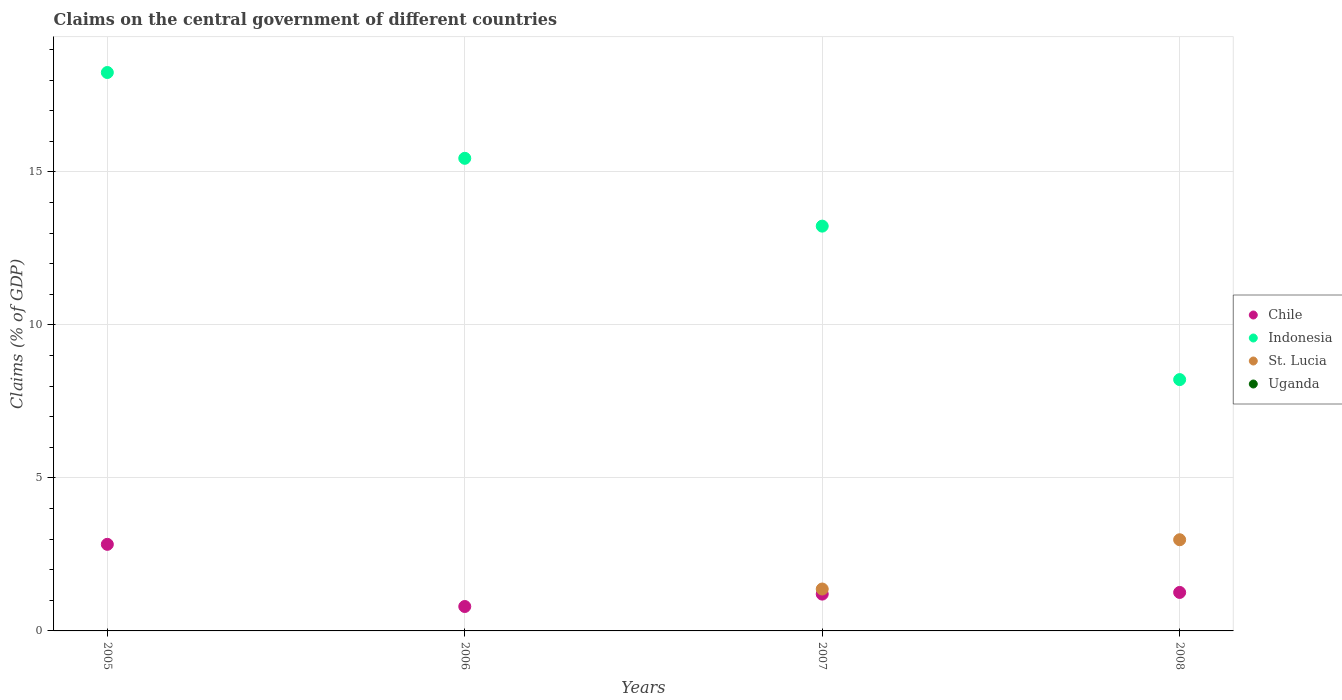Is the number of dotlines equal to the number of legend labels?
Give a very brief answer. No. What is the percentage of GDP claimed on the central government in Indonesia in 2006?
Your answer should be compact. 15.44. Across all years, what is the maximum percentage of GDP claimed on the central government in Indonesia?
Make the answer very short. 18.25. Across all years, what is the minimum percentage of GDP claimed on the central government in St. Lucia?
Provide a short and direct response. 0. What is the total percentage of GDP claimed on the central government in St. Lucia in the graph?
Your answer should be very brief. 4.35. What is the difference between the percentage of GDP claimed on the central government in Chile in 2006 and that in 2007?
Provide a short and direct response. -0.41. What is the difference between the percentage of GDP claimed on the central government in Chile in 2006 and the percentage of GDP claimed on the central government in St. Lucia in 2008?
Your response must be concise. -2.18. What is the average percentage of GDP claimed on the central government in Chile per year?
Your answer should be compact. 1.52. In the year 2007, what is the difference between the percentage of GDP claimed on the central government in St. Lucia and percentage of GDP claimed on the central government in Indonesia?
Give a very brief answer. -11.86. What is the ratio of the percentage of GDP claimed on the central government in Chile in 2005 to that in 2007?
Keep it short and to the point. 2.35. What is the difference between the highest and the second highest percentage of GDP claimed on the central government in Indonesia?
Your answer should be compact. 2.8. What is the difference between the highest and the lowest percentage of GDP claimed on the central government in Chile?
Offer a very short reply. 2.03. In how many years, is the percentage of GDP claimed on the central government in Uganda greater than the average percentage of GDP claimed on the central government in Uganda taken over all years?
Ensure brevity in your answer.  0. Is the sum of the percentage of GDP claimed on the central government in Chile in 2005 and 2006 greater than the maximum percentage of GDP claimed on the central government in Uganda across all years?
Provide a short and direct response. Yes. Does the percentage of GDP claimed on the central government in Chile monotonically increase over the years?
Your answer should be very brief. No. Is the percentage of GDP claimed on the central government in Uganda strictly less than the percentage of GDP claimed on the central government in Indonesia over the years?
Provide a succinct answer. Yes. How many dotlines are there?
Ensure brevity in your answer.  3. How many years are there in the graph?
Provide a short and direct response. 4. What is the difference between two consecutive major ticks on the Y-axis?
Your answer should be compact. 5. How are the legend labels stacked?
Keep it short and to the point. Vertical. What is the title of the graph?
Give a very brief answer. Claims on the central government of different countries. What is the label or title of the Y-axis?
Make the answer very short. Claims (% of GDP). What is the Claims (% of GDP) of Chile in 2005?
Your response must be concise. 2.83. What is the Claims (% of GDP) in Indonesia in 2005?
Your answer should be compact. 18.25. What is the Claims (% of GDP) of St. Lucia in 2005?
Provide a short and direct response. 0. What is the Claims (% of GDP) in Uganda in 2005?
Your answer should be compact. 0. What is the Claims (% of GDP) of Chile in 2006?
Your answer should be very brief. 0.8. What is the Claims (% of GDP) of Indonesia in 2006?
Give a very brief answer. 15.44. What is the Claims (% of GDP) in Chile in 2007?
Your response must be concise. 1.2. What is the Claims (% of GDP) in Indonesia in 2007?
Offer a very short reply. 13.23. What is the Claims (% of GDP) in St. Lucia in 2007?
Your answer should be very brief. 1.37. What is the Claims (% of GDP) of Uganda in 2007?
Ensure brevity in your answer.  0. What is the Claims (% of GDP) of Chile in 2008?
Your answer should be very brief. 1.26. What is the Claims (% of GDP) in Indonesia in 2008?
Make the answer very short. 8.21. What is the Claims (% of GDP) in St. Lucia in 2008?
Your answer should be compact. 2.98. What is the Claims (% of GDP) of Uganda in 2008?
Your response must be concise. 0. Across all years, what is the maximum Claims (% of GDP) in Chile?
Offer a very short reply. 2.83. Across all years, what is the maximum Claims (% of GDP) in Indonesia?
Give a very brief answer. 18.25. Across all years, what is the maximum Claims (% of GDP) in St. Lucia?
Give a very brief answer. 2.98. Across all years, what is the minimum Claims (% of GDP) in Chile?
Your answer should be very brief. 0.8. Across all years, what is the minimum Claims (% of GDP) in Indonesia?
Your answer should be compact. 8.21. What is the total Claims (% of GDP) in Chile in the graph?
Your answer should be very brief. 6.09. What is the total Claims (% of GDP) in Indonesia in the graph?
Offer a very short reply. 55.13. What is the total Claims (% of GDP) of St. Lucia in the graph?
Keep it short and to the point. 4.35. What is the difference between the Claims (% of GDP) of Chile in 2005 and that in 2006?
Provide a succinct answer. 2.03. What is the difference between the Claims (% of GDP) in Indonesia in 2005 and that in 2006?
Provide a short and direct response. 2.8. What is the difference between the Claims (% of GDP) in Chile in 2005 and that in 2007?
Your answer should be very brief. 1.63. What is the difference between the Claims (% of GDP) in Indonesia in 2005 and that in 2007?
Provide a succinct answer. 5.02. What is the difference between the Claims (% of GDP) of Chile in 2005 and that in 2008?
Give a very brief answer. 1.57. What is the difference between the Claims (% of GDP) in Indonesia in 2005 and that in 2008?
Provide a succinct answer. 10.03. What is the difference between the Claims (% of GDP) in Chile in 2006 and that in 2007?
Provide a succinct answer. -0.41. What is the difference between the Claims (% of GDP) in Indonesia in 2006 and that in 2007?
Offer a terse response. 2.22. What is the difference between the Claims (% of GDP) of Chile in 2006 and that in 2008?
Offer a very short reply. -0.46. What is the difference between the Claims (% of GDP) in Indonesia in 2006 and that in 2008?
Your answer should be very brief. 7.23. What is the difference between the Claims (% of GDP) in Chile in 2007 and that in 2008?
Your answer should be compact. -0.05. What is the difference between the Claims (% of GDP) in Indonesia in 2007 and that in 2008?
Make the answer very short. 5.01. What is the difference between the Claims (% of GDP) of St. Lucia in 2007 and that in 2008?
Your answer should be very brief. -1.61. What is the difference between the Claims (% of GDP) in Chile in 2005 and the Claims (% of GDP) in Indonesia in 2006?
Provide a short and direct response. -12.61. What is the difference between the Claims (% of GDP) of Chile in 2005 and the Claims (% of GDP) of Indonesia in 2007?
Your response must be concise. -10.4. What is the difference between the Claims (% of GDP) in Chile in 2005 and the Claims (% of GDP) in St. Lucia in 2007?
Provide a short and direct response. 1.46. What is the difference between the Claims (% of GDP) in Indonesia in 2005 and the Claims (% of GDP) in St. Lucia in 2007?
Your answer should be very brief. 16.88. What is the difference between the Claims (% of GDP) of Chile in 2005 and the Claims (% of GDP) of Indonesia in 2008?
Your response must be concise. -5.38. What is the difference between the Claims (% of GDP) in Chile in 2005 and the Claims (% of GDP) in St. Lucia in 2008?
Provide a short and direct response. -0.15. What is the difference between the Claims (% of GDP) of Indonesia in 2005 and the Claims (% of GDP) of St. Lucia in 2008?
Keep it short and to the point. 15.27. What is the difference between the Claims (% of GDP) of Chile in 2006 and the Claims (% of GDP) of Indonesia in 2007?
Keep it short and to the point. -12.43. What is the difference between the Claims (% of GDP) of Chile in 2006 and the Claims (% of GDP) of St. Lucia in 2007?
Keep it short and to the point. -0.57. What is the difference between the Claims (% of GDP) of Indonesia in 2006 and the Claims (% of GDP) of St. Lucia in 2007?
Your answer should be compact. 14.07. What is the difference between the Claims (% of GDP) in Chile in 2006 and the Claims (% of GDP) in Indonesia in 2008?
Give a very brief answer. -7.41. What is the difference between the Claims (% of GDP) in Chile in 2006 and the Claims (% of GDP) in St. Lucia in 2008?
Keep it short and to the point. -2.18. What is the difference between the Claims (% of GDP) of Indonesia in 2006 and the Claims (% of GDP) of St. Lucia in 2008?
Offer a very short reply. 12.46. What is the difference between the Claims (% of GDP) in Chile in 2007 and the Claims (% of GDP) in Indonesia in 2008?
Offer a very short reply. -7.01. What is the difference between the Claims (% of GDP) of Chile in 2007 and the Claims (% of GDP) of St. Lucia in 2008?
Make the answer very short. -1.78. What is the difference between the Claims (% of GDP) in Indonesia in 2007 and the Claims (% of GDP) in St. Lucia in 2008?
Your answer should be very brief. 10.25. What is the average Claims (% of GDP) in Chile per year?
Offer a very short reply. 1.52. What is the average Claims (% of GDP) in Indonesia per year?
Offer a terse response. 13.78. What is the average Claims (% of GDP) in St. Lucia per year?
Provide a short and direct response. 1.09. In the year 2005, what is the difference between the Claims (% of GDP) of Chile and Claims (% of GDP) of Indonesia?
Your answer should be very brief. -15.42. In the year 2006, what is the difference between the Claims (% of GDP) in Chile and Claims (% of GDP) in Indonesia?
Ensure brevity in your answer.  -14.64. In the year 2007, what is the difference between the Claims (% of GDP) in Chile and Claims (% of GDP) in Indonesia?
Provide a succinct answer. -12.02. In the year 2007, what is the difference between the Claims (% of GDP) in Chile and Claims (% of GDP) in St. Lucia?
Your answer should be very brief. -0.17. In the year 2007, what is the difference between the Claims (% of GDP) in Indonesia and Claims (% of GDP) in St. Lucia?
Ensure brevity in your answer.  11.86. In the year 2008, what is the difference between the Claims (% of GDP) in Chile and Claims (% of GDP) in Indonesia?
Give a very brief answer. -6.95. In the year 2008, what is the difference between the Claims (% of GDP) of Chile and Claims (% of GDP) of St. Lucia?
Give a very brief answer. -1.72. In the year 2008, what is the difference between the Claims (% of GDP) of Indonesia and Claims (% of GDP) of St. Lucia?
Keep it short and to the point. 5.23. What is the ratio of the Claims (% of GDP) of Chile in 2005 to that in 2006?
Keep it short and to the point. 3.55. What is the ratio of the Claims (% of GDP) of Indonesia in 2005 to that in 2006?
Give a very brief answer. 1.18. What is the ratio of the Claims (% of GDP) in Chile in 2005 to that in 2007?
Give a very brief answer. 2.35. What is the ratio of the Claims (% of GDP) of Indonesia in 2005 to that in 2007?
Provide a succinct answer. 1.38. What is the ratio of the Claims (% of GDP) of Chile in 2005 to that in 2008?
Give a very brief answer. 2.25. What is the ratio of the Claims (% of GDP) of Indonesia in 2005 to that in 2008?
Ensure brevity in your answer.  2.22. What is the ratio of the Claims (% of GDP) in Chile in 2006 to that in 2007?
Make the answer very short. 0.66. What is the ratio of the Claims (% of GDP) of Indonesia in 2006 to that in 2007?
Ensure brevity in your answer.  1.17. What is the ratio of the Claims (% of GDP) of Chile in 2006 to that in 2008?
Your response must be concise. 0.63. What is the ratio of the Claims (% of GDP) in Indonesia in 2006 to that in 2008?
Offer a very short reply. 1.88. What is the ratio of the Claims (% of GDP) of Chile in 2007 to that in 2008?
Make the answer very short. 0.96. What is the ratio of the Claims (% of GDP) in Indonesia in 2007 to that in 2008?
Provide a short and direct response. 1.61. What is the ratio of the Claims (% of GDP) of St. Lucia in 2007 to that in 2008?
Offer a very short reply. 0.46. What is the difference between the highest and the second highest Claims (% of GDP) of Chile?
Offer a very short reply. 1.57. What is the difference between the highest and the second highest Claims (% of GDP) in Indonesia?
Your response must be concise. 2.8. What is the difference between the highest and the lowest Claims (% of GDP) in Chile?
Your response must be concise. 2.03. What is the difference between the highest and the lowest Claims (% of GDP) in Indonesia?
Provide a succinct answer. 10.03. What is the difference between the highest and the lowest Claims (% of GDP) in St. Lucia?
Your answer should be very brief. 2.98. 